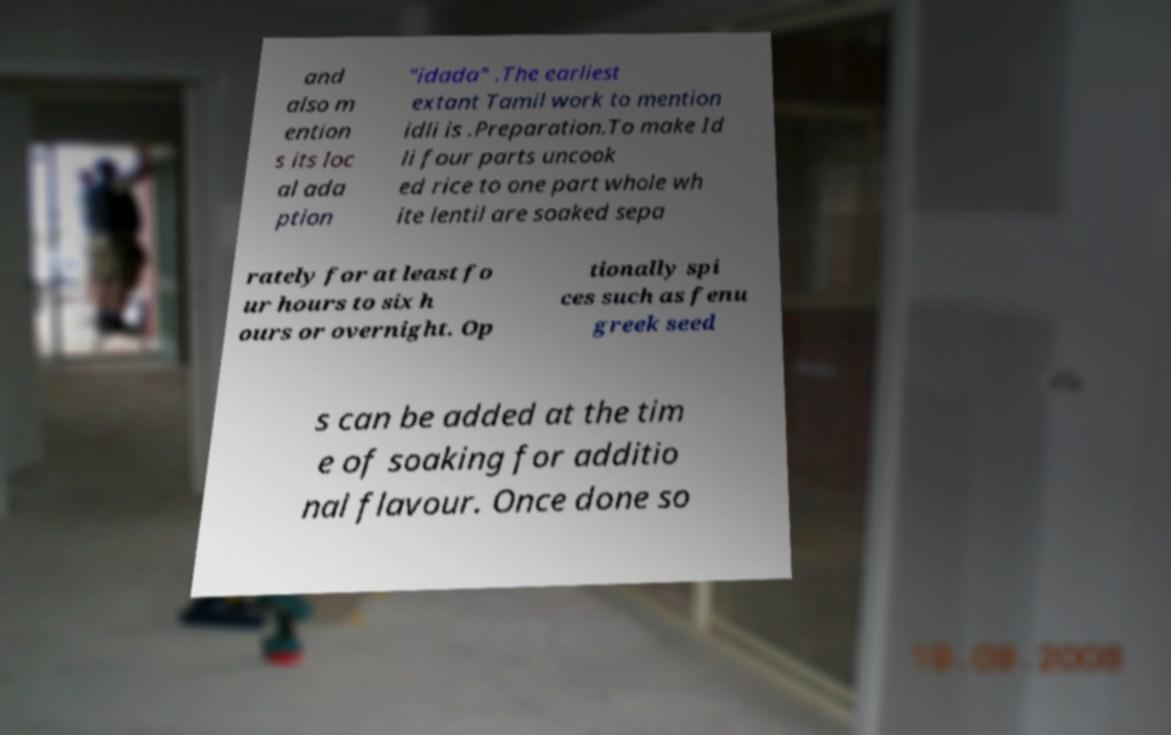Could you extract and type out the text from this image? and also m ention s its loc al ada ption "idada" .The earliest extant Tamil work to mention idli is .Preparation.To make Id li four parts uncook ed rice to one part whole wh ite lentil are soaked sepa rately for at least fo ur hours to six h ours or overnight. Op tionally spi ces such as fenu greek seed s can be added at the tim e of soaking for additio nal flavour. Once done so 